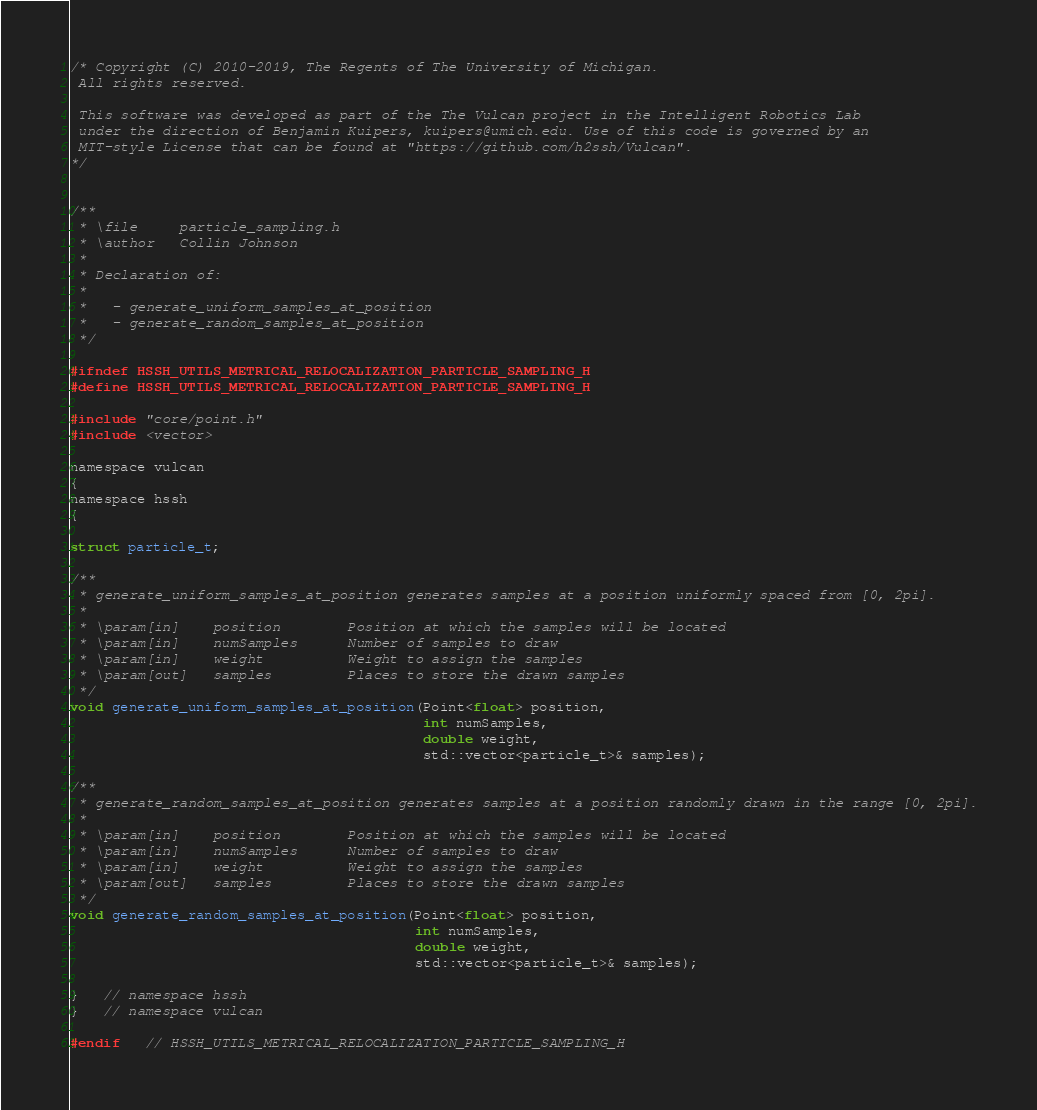Convert code to text. <code><loc_0><loc_0><loc_500><loc_500><_C_>/* Copyright (C) 2010-2019, The Regents of The University of Michigan.
 All rights reserved.

 This software was developed as part of the The Vulcan project in the Intelligent Robotics Lab
 under the direction of Benjamin Kuipers, kuipers@umich.edu. Use of this code is governed by an
 MIT-style License that can be found at "https://github.com/h2ssh/Vulcan".
*/


/**
 * \file     particle_sampling.h
 * \author   Collin Johnson
 *
 * Declaration of:
 *
 *   - generate_uniform_samples_at_position
 *   - generate_random_samples_at_position
 */

#ifndef HSSH_UTILS_METRICAL_RELOCALIZATION_PARTICLE_SAMPLING_H
#define HSSH_UTILS_METRICAL_RELOCALIZATION_PARTICLE_SAMPLING_H

#include "core/point.h"
#include <vector>

namespace vulcan
{
namespace hssh
{

struct particle_t;

/**
 * generate_uniform_samples_at_position generates samples at a position uniformly spaced from [0, 2pi].
 *
 * \param[in]    position        Position at which the samples will be located
 * \param[in]    numSamples      Number of samples to draw
 * \param[in]    weight          Weight to assign the samples
 * \param[out]   samples         Places to store the drawn samples
 */
void generate_uniform_samples_at_position(Point<float> position,
                                          int numSamples,
                                          double weight,
                                          std::vector<particle_t>& samples);

/**
 * generate_random_samples_at_position generates samples at a position randomly drawn in the range [0, 2pi].
 *
 * \param[in]    position        Position at which the samples will be located
 * \param[in]    numSamples      Number of samples to draw
 * \param[in]    weight          Weight to assign the samples
 * \param[out]   samples         Places to store the drawn samples
 */
void generate_random_samples_at_position(Point<float> position,
                                         int numSamples,
                                         double weight,
                                         std::vector<particle_t>& samples);

}   // namespace hssh
}   // namespace vulcan

#endif   // HSSH_UTILS_METRICAL_RELOCALIZATION_PARTICLE_SAMPLING_H
</code> 